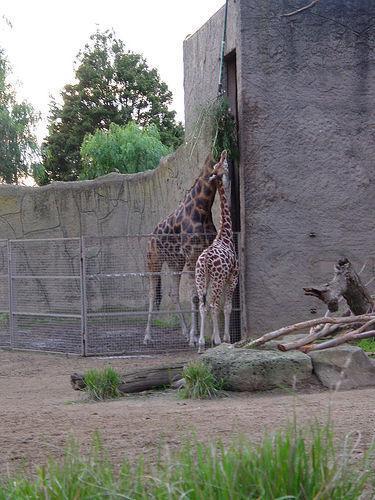How many buildings are there?
Give a very brief answer. 1. 